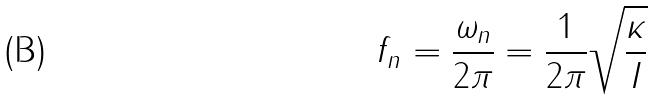<formula> <loc_0><loc_0><loc_500><loc_500>f _ { n } = \frac { \omega _ { n } } { 2 \pi } = \frac { 1 } { 2 \pi } \sqrt { \frac { \kappa } { I } }</formula> 